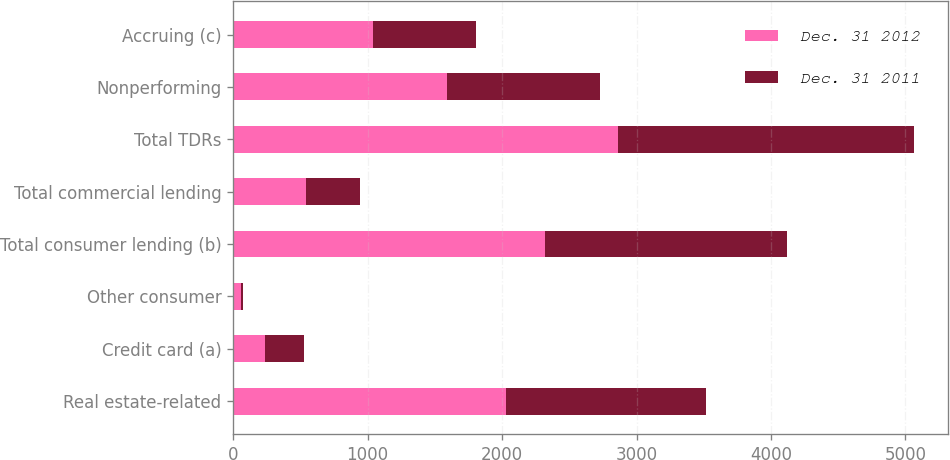<chart> <loc_0><loc_0><loc_500><loc_500><stacked_bar_chart><ecel><fcel>Real estate-related<fcel>Credit card (a)<fcel>Other consumer<fcel>Total consumer lending (b)<fcel>Total commercial lending<fcel>Total TDRs<fcel>Nonperforming<fcel>Accruing (c)<nl><fcel>Dec. 31 2012<fcel>2028<fcel>233<fcel>57<fcel>2318<fcel>541<fcel>2859<fcel>1589<fcel>1037<nl><fcel>Dec. 31 2011<fcel>1492<fcel>291<fcel>15<fcel>1798<fcel>405<fcel>2203<fcel>1141<fcel>771<nl></chart> 